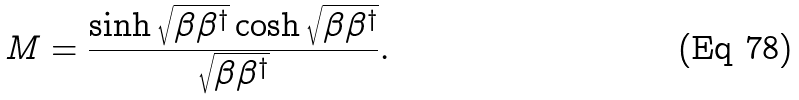Convert formula to latex. <formula><loc_0><loc_0><loc_500><loc_500>M = \frac { \sinh \sqrt { \beta \beta ^ { \dagger } } \cosh \sqrt { \beta \beta ^ { \dagger } } } { \sqrt { \beta \beta ^ { \dagger } } } .</formula> 